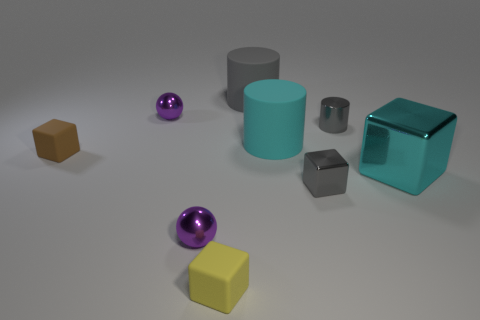What lighting conditions are present in this image? The image displays soft and diffuse lighting, as evidenced by the gentle shadows and the lack of harsh highlights on the objects. This suggests an indoor setting with possibly overhead ambient lighting. 